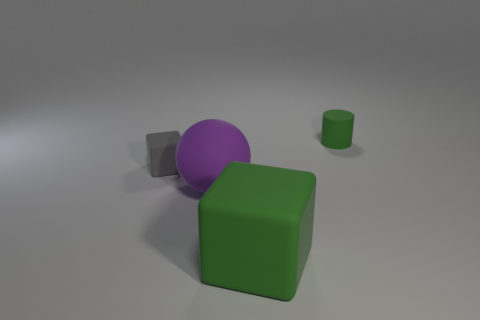Add 3 big things. How many objects exist? 7 Subtract all balls. How many objects are left? 3 Add 4 small green rubber cylinders. How many small green rubber cylinders are left? 5 Add 4 red matte objects. How many red matte objects exist? 4 Subtract 0 purple cubes. How many objects are left? 4 Subtract all small cyan metal balls. Subtract all green cylinders. How many objects are left? 3 